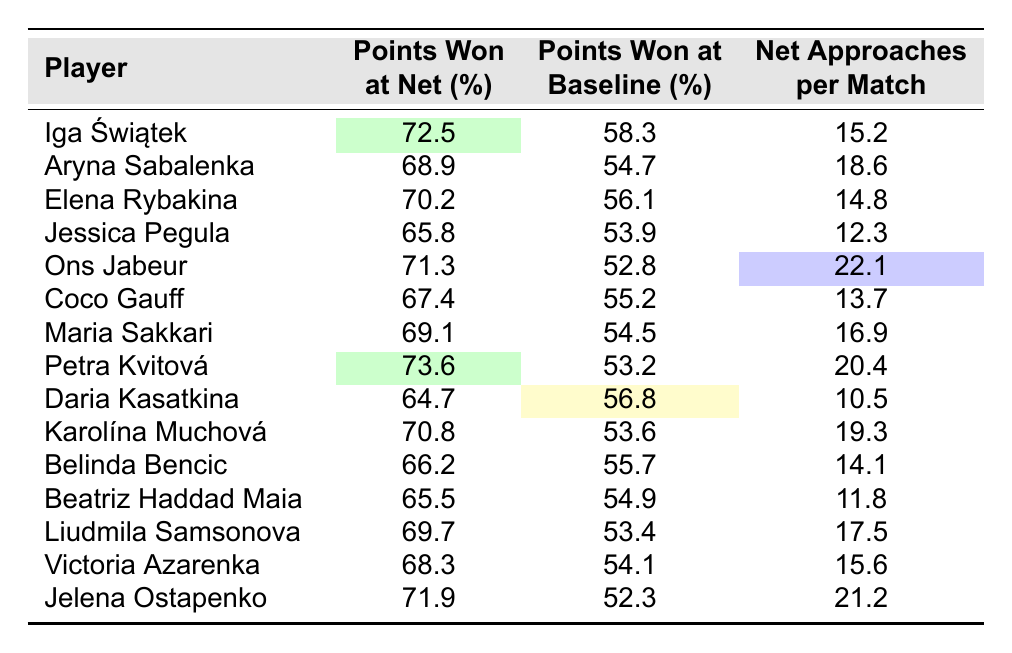What percentage of points did Iga Świątek win at the net? Iga Świątek's "Points Won at Net (%)" value from the table is 72.5%.
Answer: 72.5% Which player has the highest percentage of points won at the net? By comparing the "Points Won at Net (%)" values, Petra Kvitová has the highest percentage at 73.6%.
Answer: Petra Kvitová What is the difference in points won at the baseline between Aryna Sabalenka and Daria Kasatkina? Aryna Sabalenka won 54.7% of her baseline points, while Daria Kasatkina won 56.8%. The difference is 56.8% - 54.7% = 2.1%.
Answer: 2.1% What is the average percentage of points won at the net for the players listed? The percentages for points won at the net are: 72.5, 68.9, 70.2, 65.8, 71.3, 67.4, 69.1, 73.6, 64.7, 70.8, 66.2, 65.5, 69.7, 68.3, 71.9. The sum is 1,031.2, and there are 15 players, so the average is 1,031.2 / 15 = 68.74%.
Answer: 68.74% Is it true that Jessica Pegula has more net approaches per match than Coco Gauff? Jessica Pegula has 12.3 net approaches per match, and Coco Gauff has 13.7. Since 12.3 is less than 13.7, the statement is false.
Answer: No Which player has the lowest percentage of points won at baseline? By looking at the "Points Won at Baseline (%)", Jessica Pegula has the lowest at 53.9%.
Answer: Jessica Pegula What is the total number of net approaches per match for the top three players with the highest net approach counts? The top three players in net approaches are Ons Jabeur (22.1), Petra Kvitová (20.4), and Karolína Muchová (19.3). Adding these gives 22.1 + 20.4 + 19.3 = 61.8.
Answer: 61.8 How many players have a points won at the net percentage of over 70%? The players with over 70% points won at the net are Iga Świątek, Ons Jabeur, Petra Kvitová, and Jelena Ostapenko; that makes a total of 4 players.
Answer: 4 What is the median for points won at the net among the players? First, we arrange the "Points Won at Net (%)" values: 64.7, 65.5, 65.8, 66.2, 67.4, 68.3, 68.9, 69.1, 69.7, 70.2, 70.8, 71.3, 71.9, 72.5, 73.6. There are 15 values, and the 8th value is 69.1, which is the median.
Answer: 69.1 